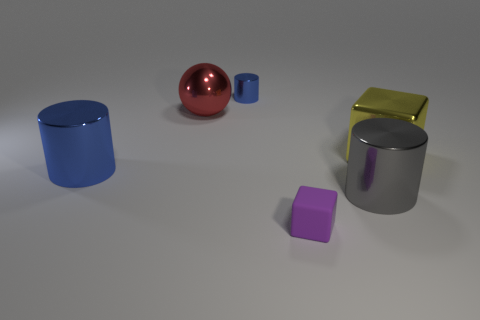What number of other things are there of the same shape as the red object?
Offer a terse response. 0. What is the material of the cylinder left of the cylinder that is behind the yellow metal block?
Provide a short and direct response. Metal. Are there any other things that are the same size as the yellow thing?
Give a very brief answer. Yes. Is the large ball made of the same material as the large thing that is to the right of the large gray metallic cylinder?
Give a very brief answer. Yes. There is a big thing that is left of the rubber object and right of the big blue metallic cylinder; what is it made of?
Your answer should be very brief. Metal. What color is the big shiny thing that is in front of the object to the left of the red object?
Give a very brief answer. Gray. There is a cylinder that is right of the tiny blue shiny cylinder; what material is it?
Your answer should be compact. Metal. Is the number of tiny cylinders less than the number of small matte spheres?
Ensure brevity in your answer.  No. There is a gray thing; is it the same shape as the blue object on the left side of the big red metal object?
Give a very brief answer. Yes. What shape is the large shiny thing that is both in front of the red thing and left of the tiny metallic thing?
Keep it short and to the point. Cylinder. 